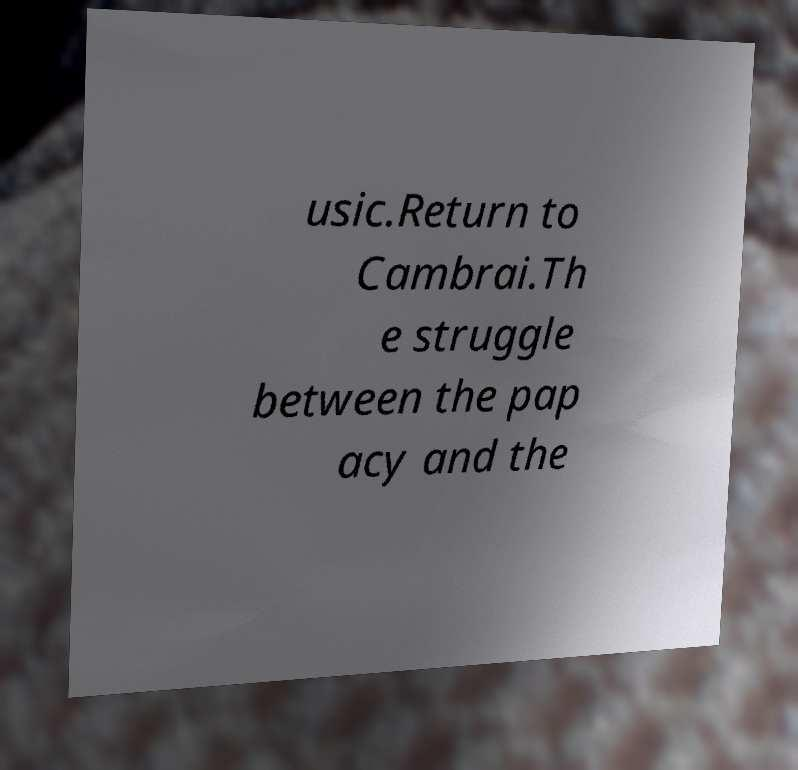What messages or text are displayed in this image? I need them in a readable, typed format. usic.Return to Cambrai.Th e struggle between the pap acy and the 